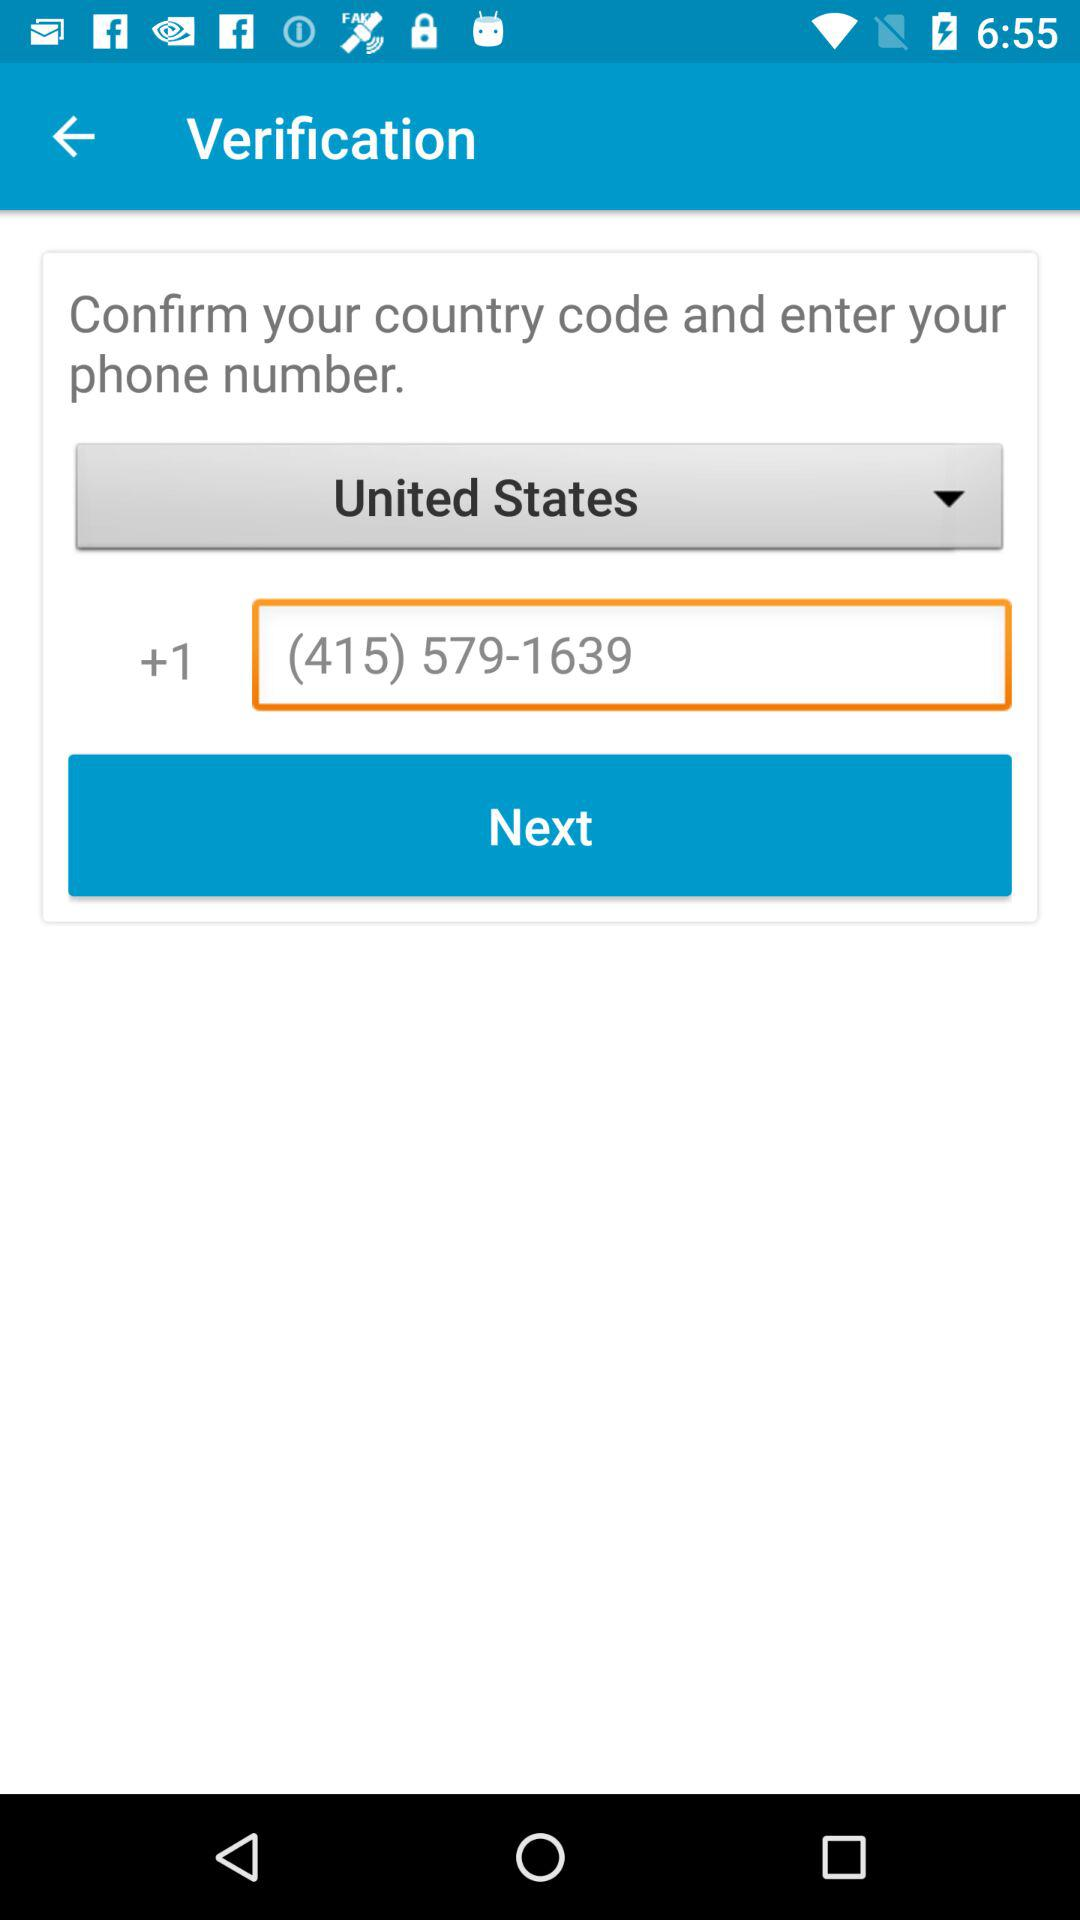What is the entered number? The entered number is (415) 579-1639. 